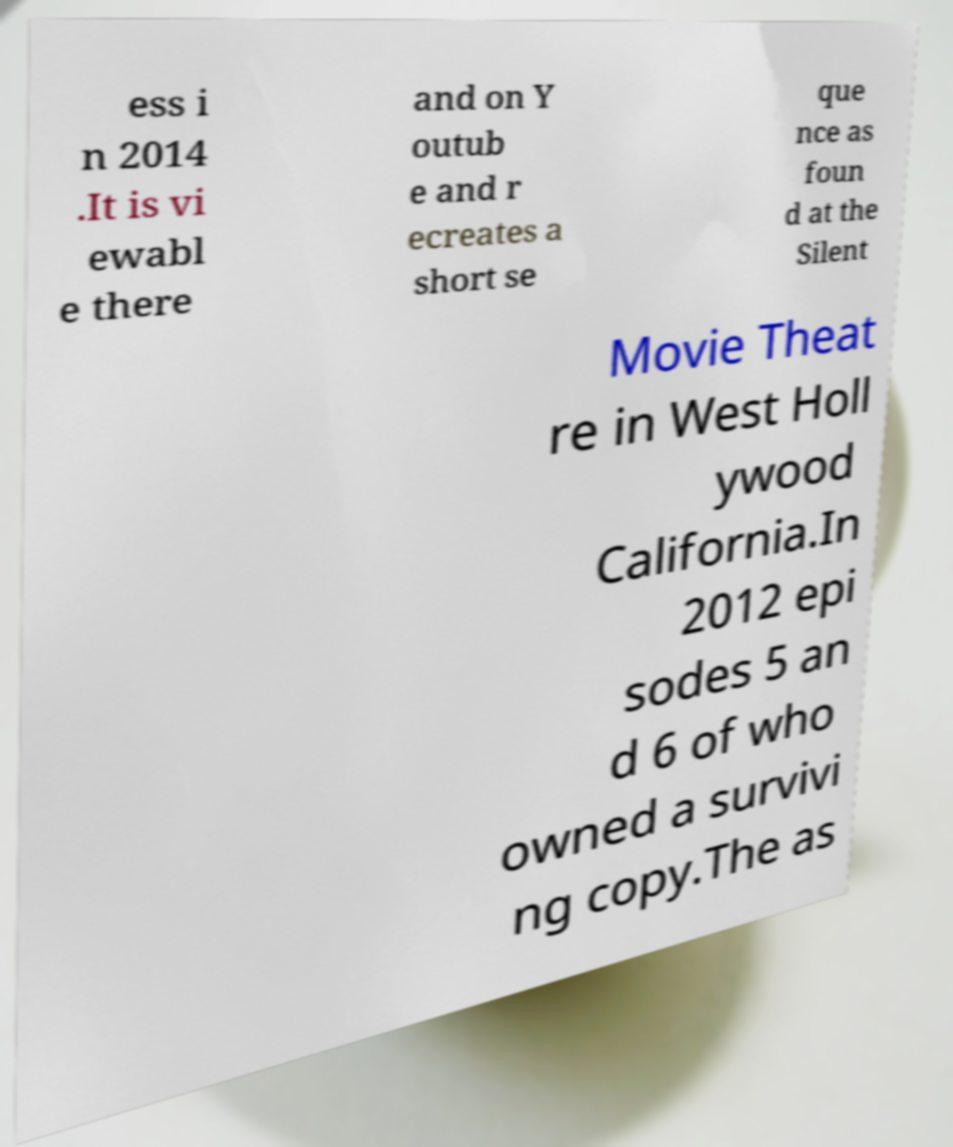Can you accurately transcribe the text from the provided image for me? ess i n 2014 .It is vi ewabl e there and on Y outub e and r ecreates a short se que nce as foun d at the Silent Movie Theat re in West Holl ywood California.In 2012 epi sodes 5 an d 6 of who owned a survivi ng copy.The as 